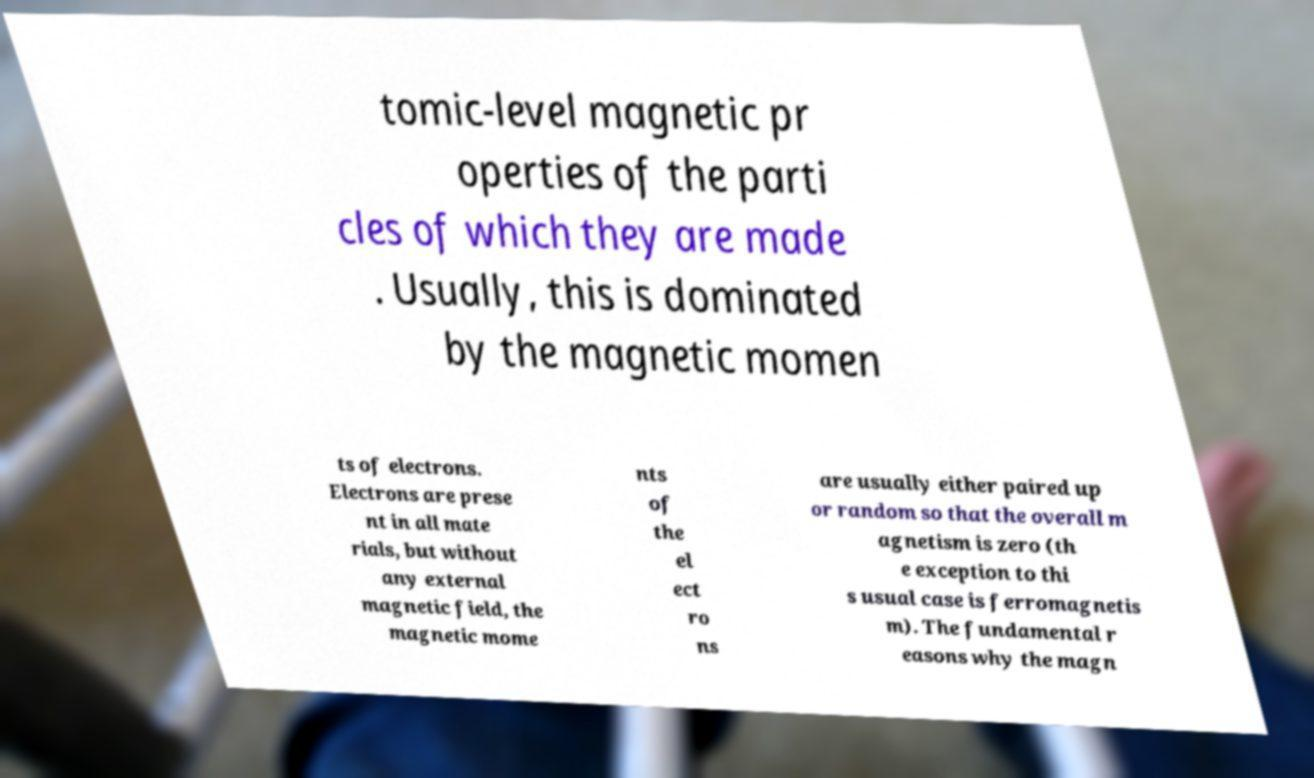For documentation purposes, I need the text within this image transcribed. Could you provide that? tomic-level magnetic pr operties of the parti cles of which they are made . Usually, this is dominated by the magnetic momen ts of electrons. Electrons are prese nt in all mate rials, but without any external magnetic field, the magnetic mome nts of the el ect ro ns are usually either paired up or random so that the overall m agnetism is zero (th e exception to thi s usual case is ferromagnetis m). The fundamental r easons why the magn 